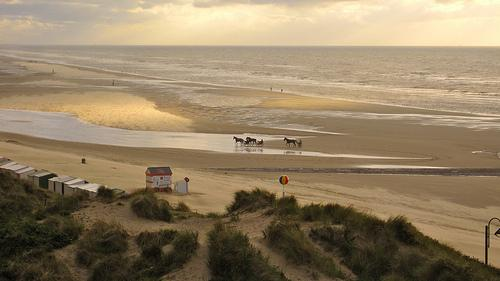Describe any sports equipment found in the image and its color. A red, yellow, and blue colored ball is present in the dirt. Name two pieces of human-made structures that can be found on the beach. A metal light pole and a black metal light on a pole, both found along the shore. What kind of plant life can be found in the image, and where are they located? Tall grass and shrubs growing on the sand dunes beside the beach. Discuss the interactions between people and horses on the beach. People are walking on the beach, some with horses, and one person is being pulled by a horse. What is a possible activity people could be doing near the water's edge in the image? People could be swimming, walking, or simply enjoying the calm waters and sunshine on the beach. What type of buildings or structures can be found on the beach and their purpose? There is a small white house, a shack, a row of changing room stalls, and a small building on the side of the ocean, possibly used for storage or concessions. Mention the main animal featured in the image and describe their activity. Horses walking along the shore, with one horse pulling a man on the wet sand. Describe the condition of the sand in the image, and if there is anything unique about it. The sandy beach is both wet and dry, with beige colored sand above the waterline and reflections of horses on the wet sand. Explain how the water is behaving in the image and the effect it has on the beach. Calm and choppy waters create small waves on the beach, leaving wet sand and water pools from the ocean. Identify the type of landscape in the image along with the primary weather condition seen. Golden beach scene with cloudy sky and patches of sunshine shining through the clouds. 